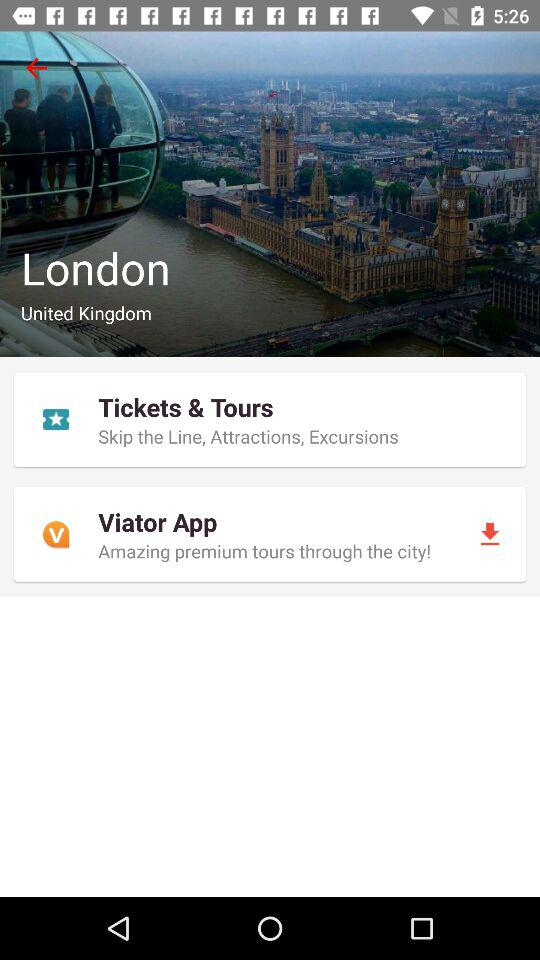What is the location? The location is London, the United Kingdom. 